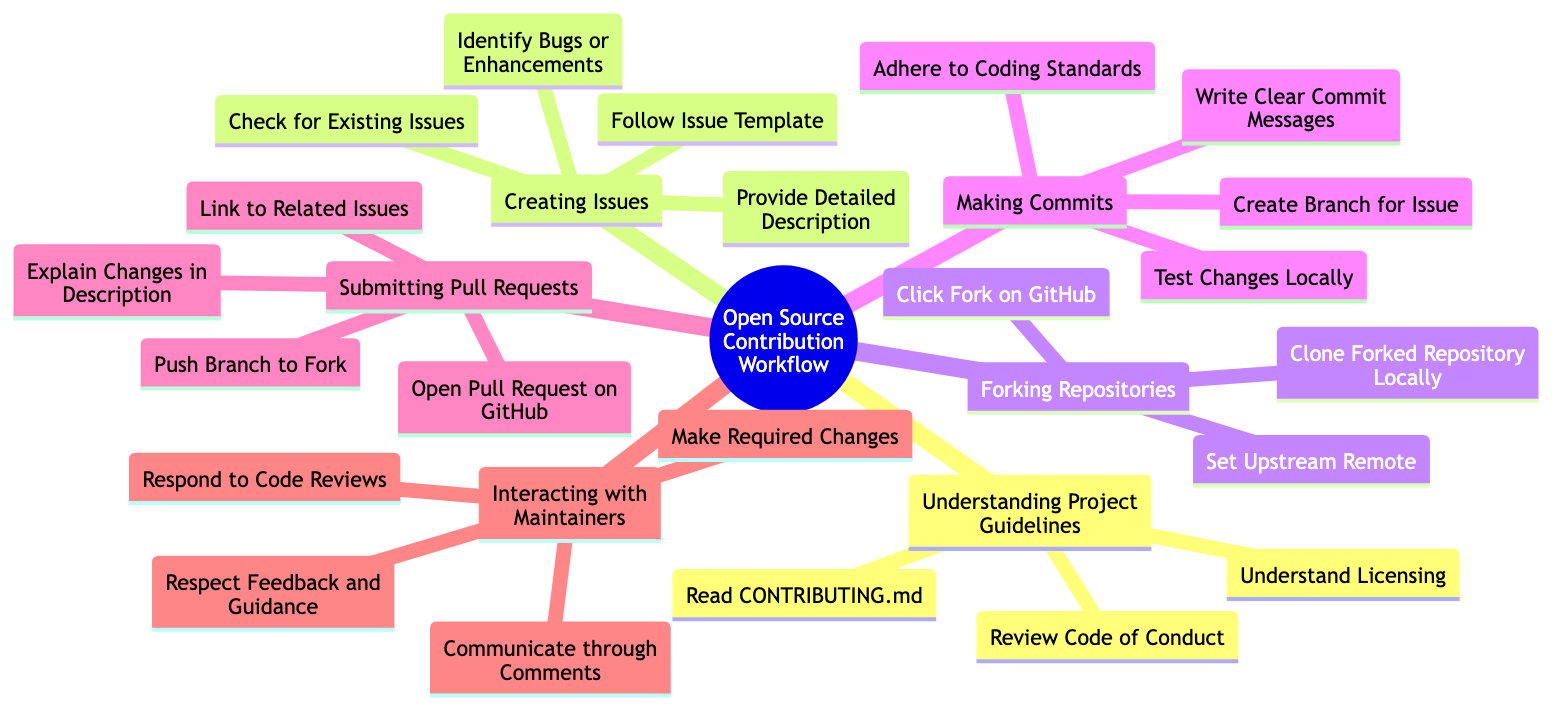What are the elements under "Understanding Project Guidelines"? The diagram lists three elements under this node: "Read CONTRIBUTING.md", "Review Code of Conduct", and "Understand Licensing".
Answer: Read CONTRIBUTING.md, Review Code of Conduct, Understand Licensing How many steps are listed under "Creating Issues"? By counting the elements under the "Creating Issues" node, we find there are four listed: "Identify Bugs or Enhancements", "Check for Existing Issues", "Follow Issue Template", and "Provide Detailed Description".
Answer: 4 What is the first action in the "Forking Repositories" process? The diagram indicates that the first action listed under "Forking Repositories" is "Click Fork on GitHub".
Answer: Click Fork on GitHub What is the relationship between "Making Commits" and "Submitting Pull Requests"? The two nodes represent sequential steps in the open-source contribution workflow, where "Making Commits" must be completed before "Submitting Pull Requests" can take place.
Answer: Sequential steps What do you need to do before opening a pull request? The diagram states that before opening a pull request, you must "Push Branch to Fork".
Answer: Push Branch to Fork How many elements are listed under "Interacting with Maintainers"? Counting the elements, we find there are four listed: "Respond to Code Reviews", "Make Required Changes", "Communicate through Comments", and "Respect Feedback and Guidance".
Answer: 4 What must you do after writing clear commit messages? According to the diagram, after writing clear commit messages, the next step is to "Adhere to Coding Standards".
Answer: Adhere to Coding Standards What action is required after identifying bugs? The diagram indicates after identifying bugs, you should "Check for Existing Issues".
Answer: Check for Existing Issues What is the last step in the "Interacting with Maintainers" section? The last step listed in that section is "Respect Feedback and Guidance".
Answer: Respect Feedback and Guidance 